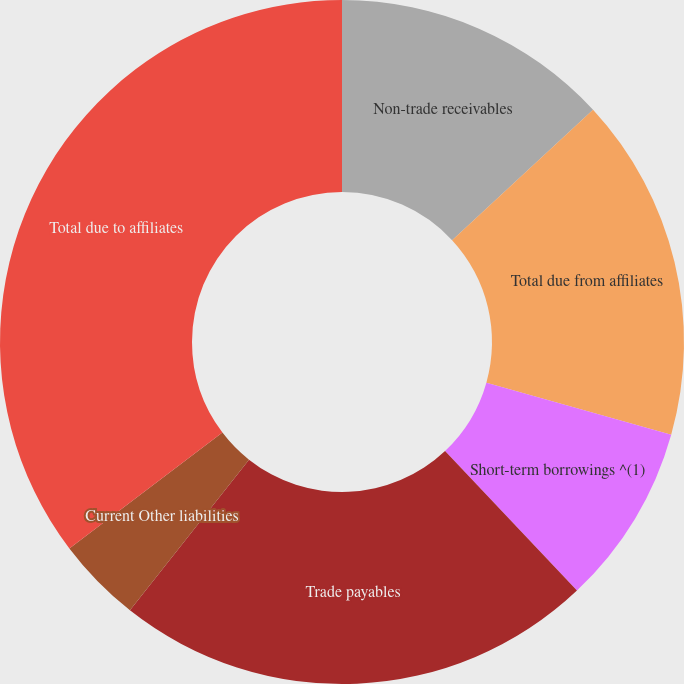<chart> <loc_0><loc_0><loc_500><loc_500><pie_chart><fcel>Non-trade receivables<fcel>Total due from affiliates<fcel>Short-term borrowings ^(1)<fcel>Trade payables<fcel>Current Other liabilities<fcel>Total due to affiliates<nl><fcel>13.12%<fcel>16.25%<fcel>8.58%<fcel>22.7%<fcel>4.04%<fcel>35.32%<nl></chart> 